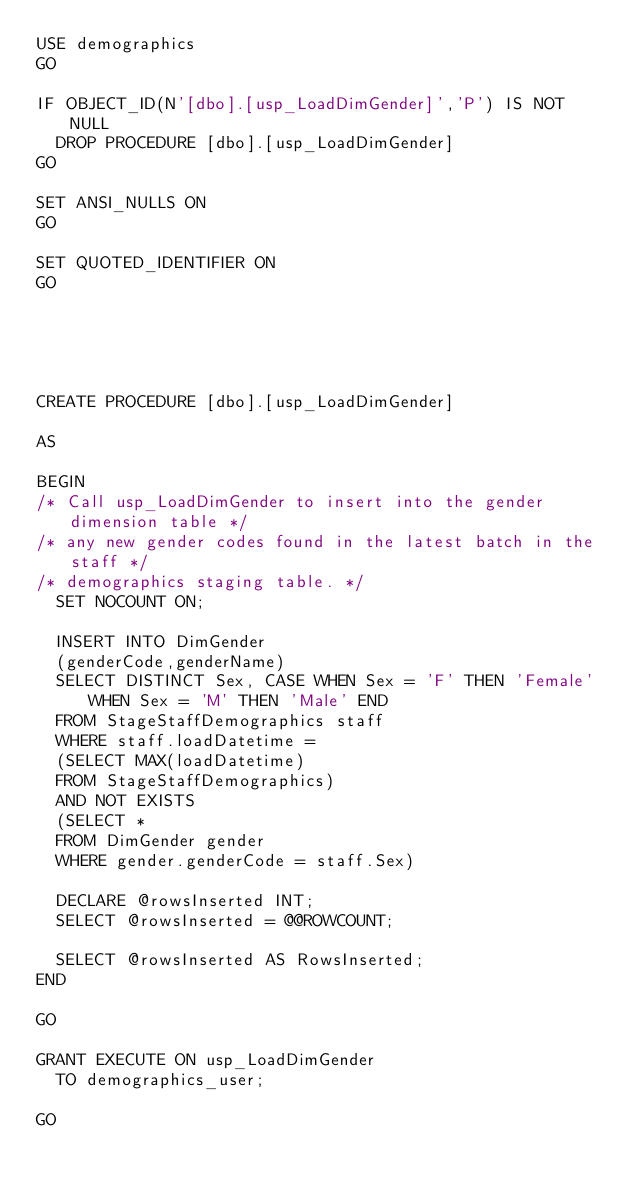<code> <loc_0><loc_0><loc_500><loc_500><_SQL_>USE demographics
GO

IF OBJECT_ID(N'[dbo].[usp_LoadDimGender]','P') IS NOT NULL
	DROP PROCEDURE [dbo].[usp_LoadDimGender]
GO

SET ANSI_NULLS ON
GO

SET QUOTED_IDENTIFIER ON
GO





CREATE PROCEDURE [dbo].[usp_LoadDimGender]   

AS

BEGIN
/* Call usp_LoadDimGender to insert into the gender dimension table */
/* any new gender codes found in the latest batch in the staff */
/* demographics staging table. */
	SET NOCOUNT ON; 

	INSERT INTO DimGender 
	(genderCode,genderName)
	SELECT DISTINCT Sex, CASE WHEN Sex = 'F' THEN 'Female' WHEN Sex = 'M' THEN 'Male' END
	FROM StageStaffDemographics staff
	WHERE staff.loadDatetime =
	(SELECT MAX(loadDatetime) 
	FROM StageStaffDemographics)
	AND NOT EXISTS
	(SELECT *
	FROM DimGender gender
	WHERE gender.genderCode = staff.Sex)

	DECLARE @rowsInserted INT;
	SELECT @rowsInserted = @@ROWCOUNT;

	SELECT @rowsInserted AS RowsInserted;	
END

GO

GRANT EXECUTE ON usp_LoadDimGender
	TO demographics_user;

GO


</code> 